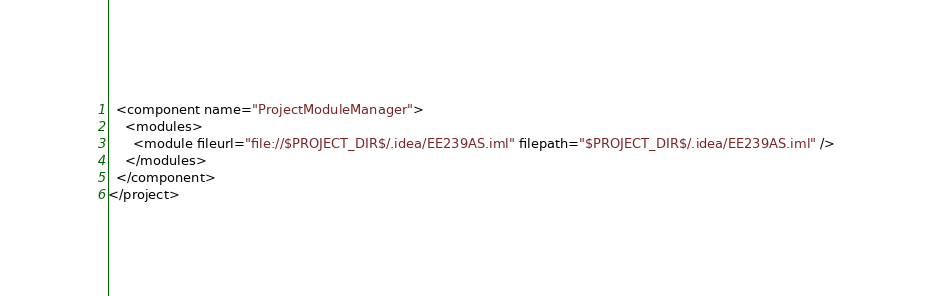Convert code to text. <code><loc_0><loc_0><loc_500><loc_500><_XML_>  <component name="ProjectModuleManager">
    <modules>
      <module fileurl="file://$PROJECT_DIR$/.idea/EE239AS.iml" filepath="$PROJECT_DIR$/.idea/EE239AS.iml" />
    </modules>
  </component>
</project></code> 